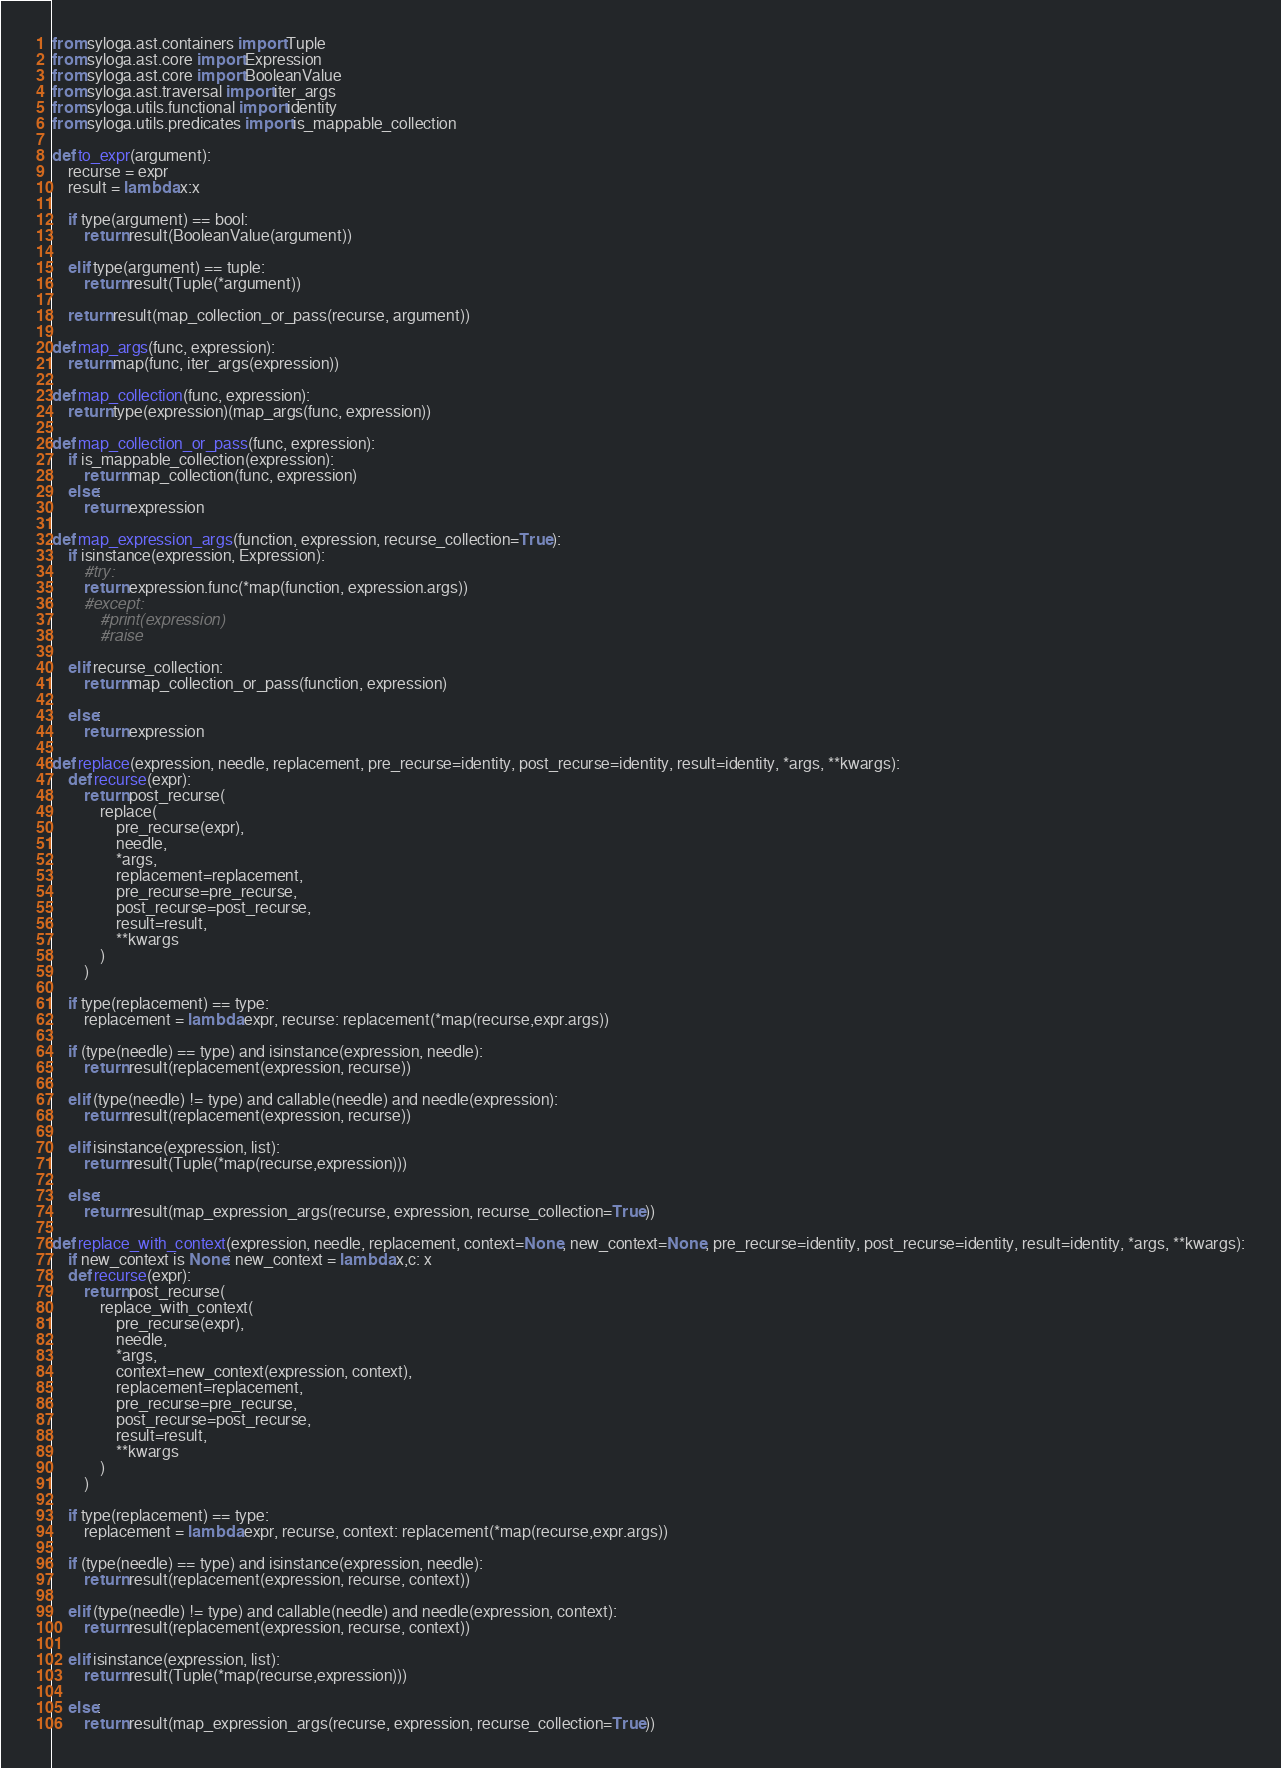Convert code to text. <code><loc_0><loc_0><loc_500><loc_500><_Python_>
from syloga.ast.containers import Tuple
from syloga.ast.core import Expression
from syloga.ast.core import BooleanValue
from syloga.ast.traversal import iter_args
from syloga.utils.functional import identity
from syloga.utils.predicates import is_mappable_collection

def to_expr(argument):
    recurse = expr
    result = lambda x:x
    
    if type(argument) == bool:
        return result(BooleanValue(argument))
    
    elif type(argument) == tuple:
        return result(Tuple(*argument))
    
    return result(map_collection_or_pass(recurse, argument))

def map_args(func, expression):
    return map(func, iter_args(expression))

def map_collection(func, expression):
    return type(expression)(map_args(func, expression))

def map_collection_or_pass(func, expression):
    if is_mappable_collection(expression):
        return map_collection(func, expression)
    else:
        return expression

def map_expression_args(function, expression, recurse_collection=True):
    if isinstance(expression, Expression):
        #try:
        return expression.func(*map(function, expression.args))
        #except:
            #print(expression)
            #raise
    
    elif recurse_collection:
        return map_collection_or_pass(function, expression)
    
    else:
        return expression

def replace(expression, needle, replacement, pre_recurse=identity, post_recurse=identity, result=identity, *args, **kwargs):
    def recurse(expr): 
        return post_recurse(
            replace(
                pre_recurse(expr), 
                needle, 
                *args, 
                replacement=replacement,
                pre_recurse=pre_recurse, 
                post_recurse=post_recurse, 
                result=result, 
                **kwargs
            )
        )
        
    if type(replacement) == type:
        replacement = lambda expr, recurse: replacement(*map(recurse,expr.args))
        
    if (type(needle) == type) and isinstance(expression, needle):
        return result(replacement(expression, recurse))
    
    elif (type(needle) != type) and callable(needle) and needle(expression):
        return result(replacement(expression, recurse))
    
    elif isinstance(expression, list):
        return result(Tuple(*map(recurse,expression)))

    else: 
        return result(map_expression_args(recurse, expression, recurse_collection=True))

def replace_with_context(expression, needle, replacement, context=None, new_context=None, pre_recurse=identity, post_recurse=identity, result=identity, *args, **kwargs):
    if new_context is None: new_context = lambda x,c: x
    def recurse(expr): 
        return post_recurse(
            replace_with_context(
                pre_recurse(expr), 
                needle, 
                *args, 
                context=new_context(expression, context),
                replacement=replacement,
                pre_recurse=pre_recurse, 
                post_recurse=post_recurse, 
                result=result, 
                **kwargs
            )
        )
    
    if type(replacement) == type:
        replacement = lambda expr, recurse, context: replacement(*map(recurse,expr.args))
        
    if (type(needle) == type) and isinstance(expression, needle):
        return result(replacement(expression, recurse, context))
    
    elif (type(needle) != type) and callable(needle) and needle(expression, context):
        return result(replacement(expression, recurse, context))
    
    elif isinstance(expression, list):
        return result(Tuple(*map(recurse,expression)))

    else: 
        return result(map_expression_args(recurse, expression, recurse_collection=True))

</code> 